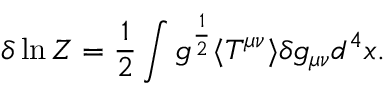<formula> <loc_0><loc_0><loc_500><loc_500>\delta \ln Z = { \frac { 1 } { 2 } } \int g ^ { \frac { 1 } { 2 } } \langle T ^ { \mu \nu } \rangle \delta g _ { \mu \nu } d ^ { 4 } x .</formula> 